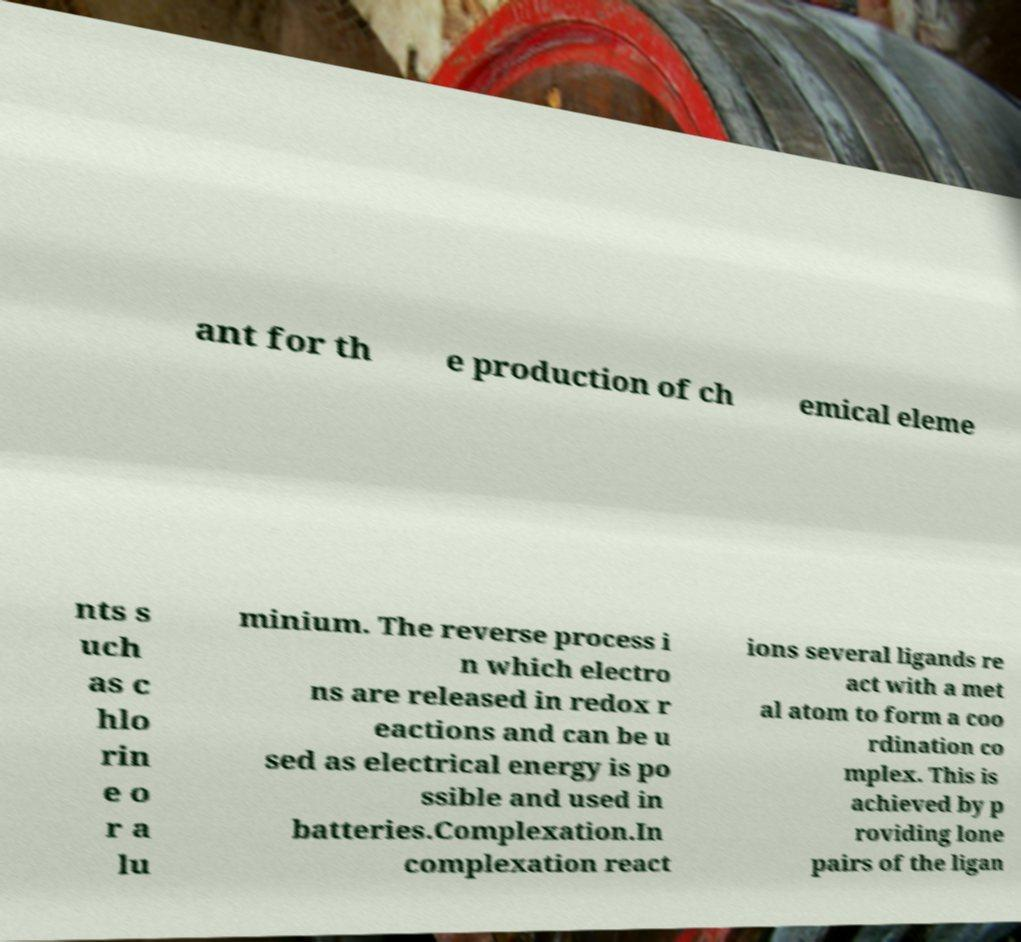There's text embedded in this image that I need extracted. Can you transcribe it verbatim? ant for th e production of ch emical eleme nts s uch as c hlo rin e o r a lu minium. The reverse process i n which electro ns are released in redox r eactions and can be u sed as electrical energy is po ssible and used in batteries.Complexation.In complexation react ions several ligands re act with a met al atom to form a coo rdination co mplex. This is achieved by p roviding lone pairs of the ligan 